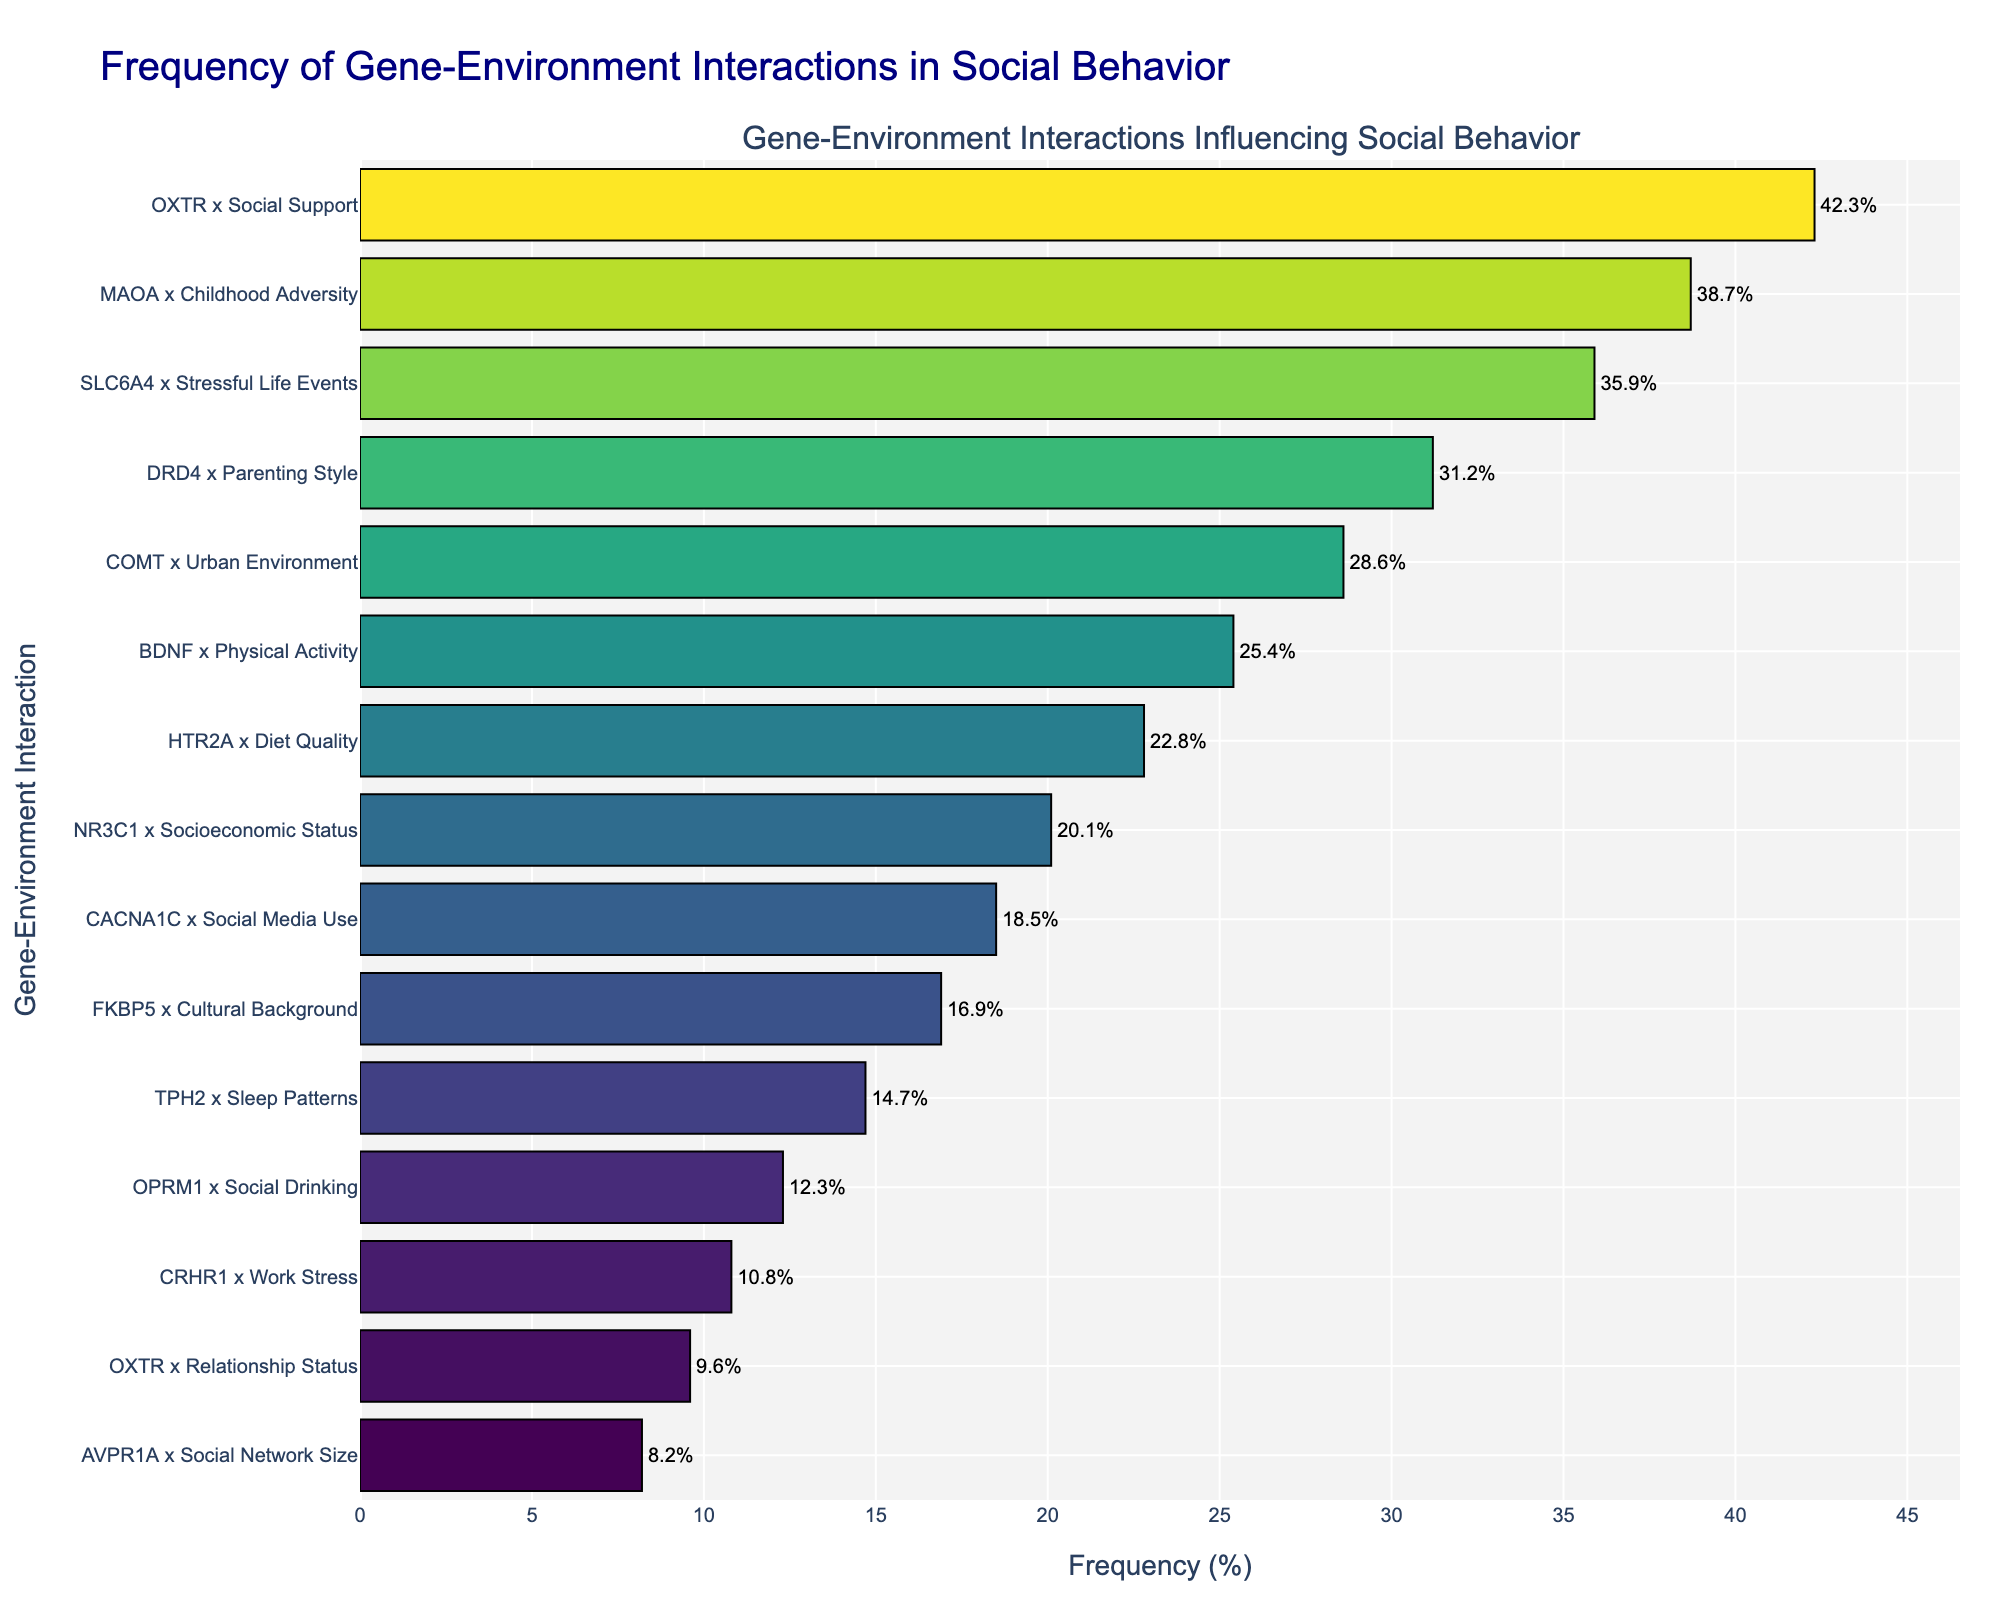Which gene-environment interaction has the highest frequency? The highest bar on the chart represents the gene-environment interaction with the highest frequency. This bar is labeled "OXTR x Social Support" and has a value of 42.3%.
Answer: OXTR x Social Support Which gene-environment interaction has a lower frequency: DRD4 x Parenting Style or BDNF x Physical Activity? By comparing the heights of the bars, "DRD4 x Parenting Style" has a frequency of 31.2%, whereas "BDNF x Physical Activity" has a frequency of 25.4%.
Answer: BDNF x Physical Activity What is the sum of the frequencies of SLC6A4 x Stressful Life Events and MAOA x Childhood Adversity? SLC6A4 x Stressful Life Events has a frequency of 35.9%, and MAOA x Childhood Adversity has a frequency of 38.7%. Adding these together gives 35.9% + 38.7% = 74.6%.
Answer: 74.6% What is the average frequency of the top three most frequent interactions? The top three interactions are OXTR x Social Support (42.3%), MAOA x Childhood Adversity (38.7%), and SLC6A4 x Stressful Life Events (35.9%). Their average frequency is calculated as (42.3 + 38.7 + 35.9) / 3.
Answer: 39.0% Which gene-environment interaction has the smallest frequency and what is its value? The smallest bar on the chart represents the gene-environment interaction with the smallest frequency. This is labeled "AVPR1A x Social Network Size" with a value of 8.2%.
Answer: AVPR1A x Social Network Size How much higher is the frequency of OXTR x Social Support compared to that of AVPR1A x Social Network Size? OXTR x Social Support has a frequency of 42.3%, and AVPR1A x Social Network Size has a frequency of 8.2%. The difference is 42.3% - 8.2% = 34.1%.
Answer: 34.1% Which has a higher frequency: TPH2 x Sleep Patterns or NR3C1 x Socioeconomic Status? Comparing the heights of the bars, TPH2 x Sleep Patterns has a frequency of 14.7%, and NR3C1 x Socioeconomic Status has a frequency of 20.1%.
Answer: NR3C1 x Socioeconomic Status What is the frequency percentage range (difference between the highest and lowest frequencies) for these gene-environment interactions? The highest frequency is 42.3% (OXTR x Social Support), and the lowest is 8.2% (AVPR1A x Social Network Size). The range is 42.3% - 8.2% = 34.1%.
Answer: 34.1% What proportion of interactions have a frequency above 20%? Count the number of bars with frequencies above 20%. There are 8 such bars out of 15 interactions in total (OXTR x Social Support, MAOA x Childhood Adversity, SLC6A4 x Stressful Life Events, etc.): 8/15 * 100.
Answer: 53.3% How does the frequency of CRHR1 x Work Stress compare to that of OPRM1 x Social Drinking? The bar for CRHR1 x Work Stress shows a frequency of 10.8%, and the bar for OPRM1 x Social Drinking shows a frequency of 12.3%. Comparing these values, 10.8% is less than 12.3%.
Answer: CRHR1 x Work Stress is lower 